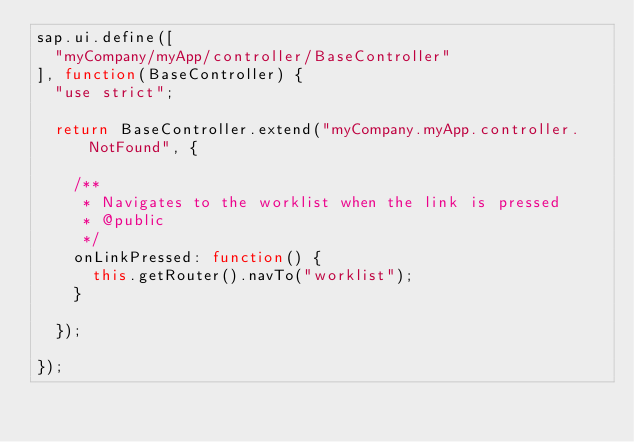<code> <loc_0><loc_0><loc_500><loc_500><_JavaScript_>sap.ui.define([
	"myCompany/myApp/controller/BaseController"
], function(BaseController) {
	"use strict";

	return BaseController.extend("myCompany.myApp.controller.NotFound", {

		/**
		 * Navigates to the worklist when the link is pressed
		 * @public
		 */
		onLinkPressed: function() {
			this.getRouter().navTo("worklist");
		}

	});

});</code> 